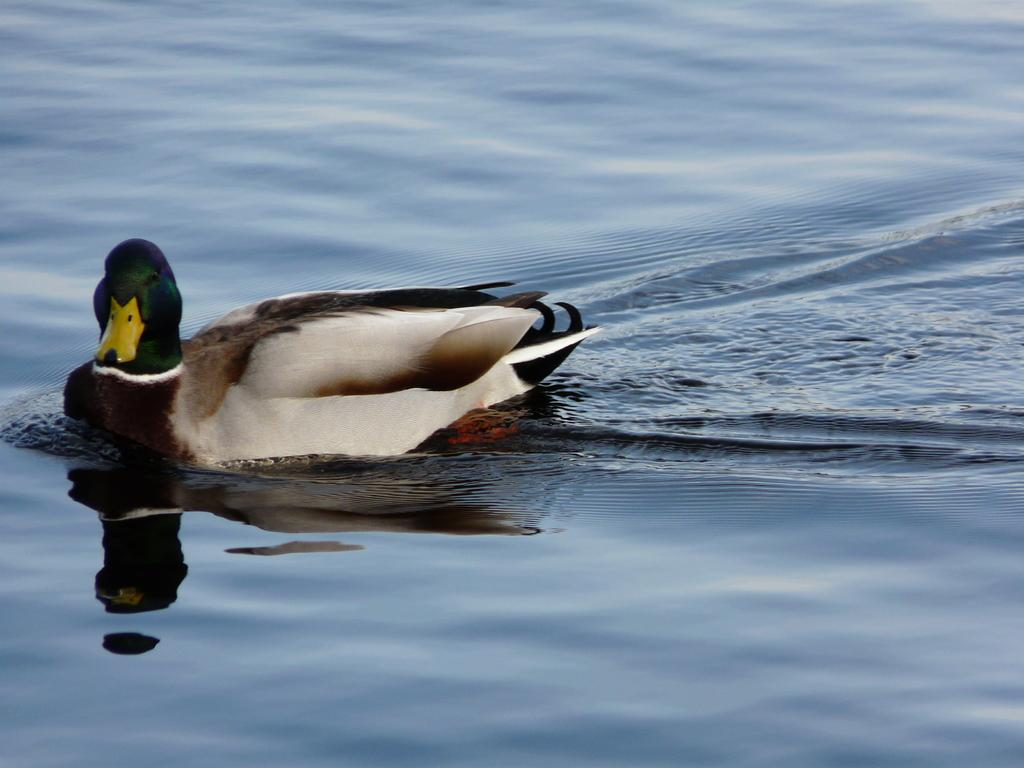What animal is present in the image? There is a duck in the image. What color combination can be observed on the duck? The duck has a white and black color combination. What is the duck doing in the image? The duck is swimming on the water. What type of stick can be seen in the duck's beak in the image? There is no stick present in the duck's beak in the image. 